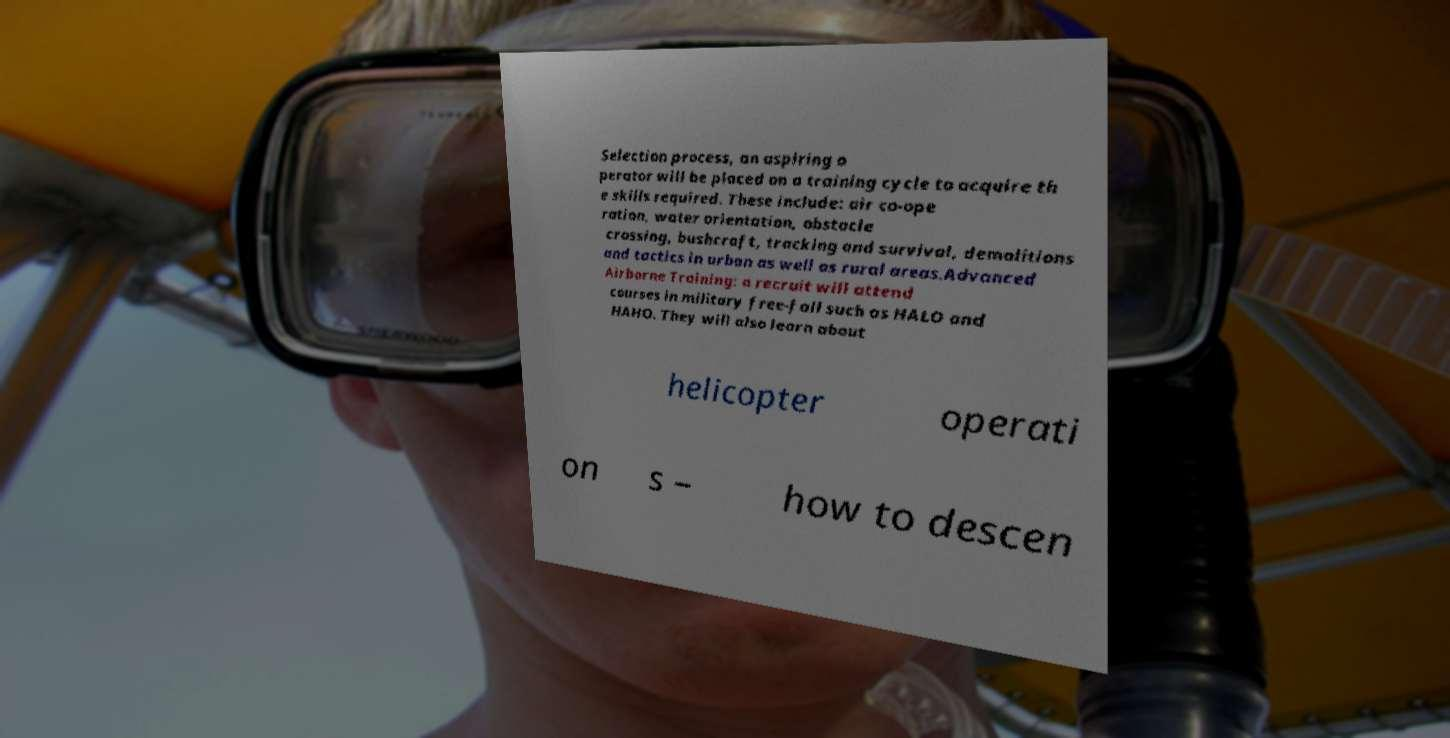Please read and relay the text visible in this image. What does it say? Selection process, an aspiring o perator will be placed on a training cycle to acquire th e skills required. These include: air co-ope ration, water orientation, obstacle crossing, bushcraft, tracking and survival, demolitions and tactics in urban as well as rural areas.Advanced Airborne Training: a recruit will attend courses in military free-fall such as HALO and HAHO. They will also learn about helicopter operati on s – how to descen 